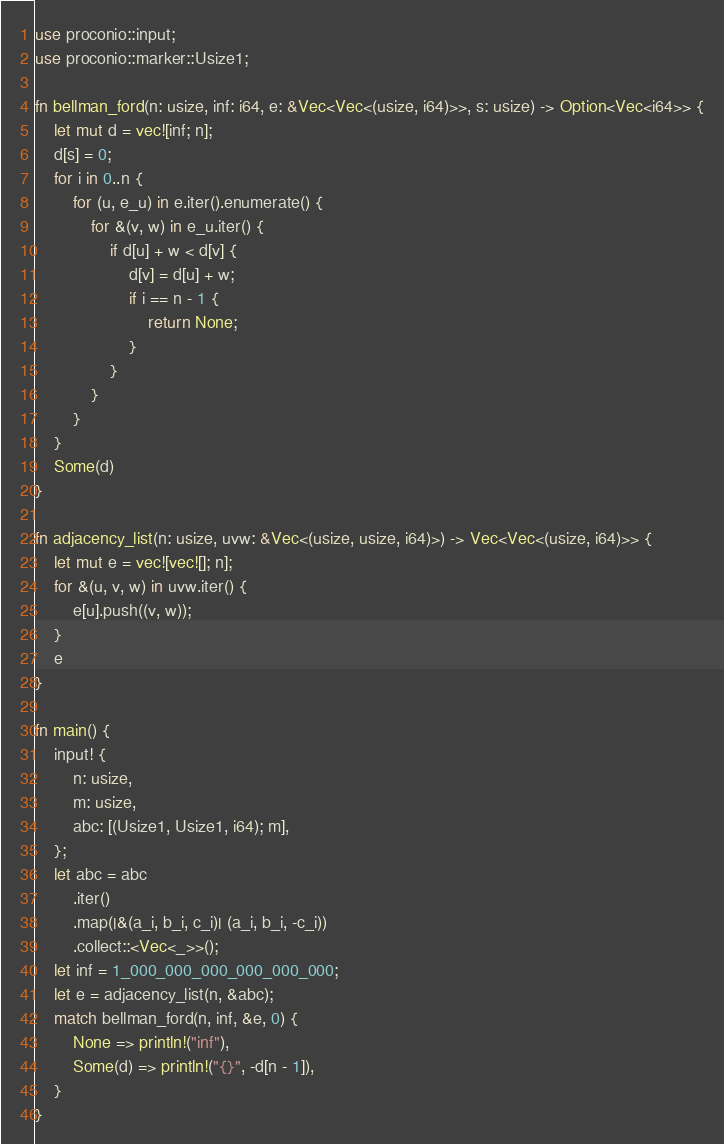<code> <loc_0><loc_0><loc_500><loc_500><_Rust_>use proconio::input;
use proconio::marker::Usize1;

fn bellman_ford(n: usize, inf: i64, e: &Vec<Vec<(usize, i64)>>, s: usize) -> Option<Vec<i64>> {
    let mut d = vec![inf; n];
    d[s] = 0;
    for i in 0..n {
        for (u, e_u) in e.iter().enumerate() {
            for &(v, w) in e_u.iter() {
                if d[u] + w < d[v] {
                    d[v] = d[u] + w;
                    if i == n - 1 {
                        return None;
                    }
                }
            }
        }
    }
    Some(d)
}

fn adjacency_list(n: usize, uvw: &Vec<(usize, usize, i64)>) -> Vec<Vec<(usize, i64)>> {
    let mut e = vec![vec![]; n];
    for &(u, v, w) in uvw.iter() {
        e[u].push((v, w));
    }
    e
}

fn main() {
    input! {
        n: usize,
        m: usize,
        abc: [(Usize1, Usize1, i64); m],
    };
    let abc = abc
        .iter()
        .map(|&(a_i, b_i, c_i)| (a_i, b_i, -c_i))
        .collect::<Vec<_>>();
    let inf = 1_000_000_000_000_000_000;
    let e = adjacency_list(n, &abc);
    match bellman_ford(n, inf, &e, 0) {
        None => println!("inf"),
        Some(d) => println!("{}", -d[n - 1]),
    }
}
</code> 